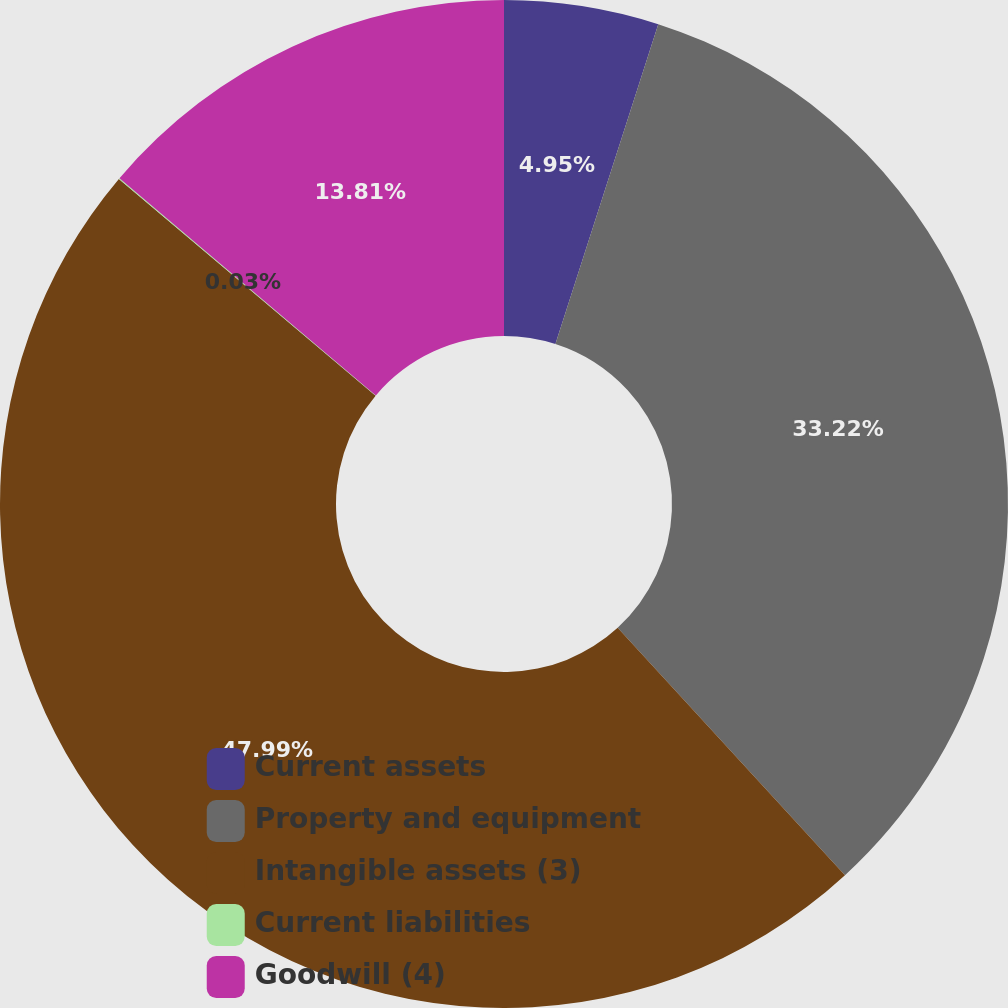Convert chart to OTSL. <chart><loc_0><loc_0><loc_500><loc_500><pie_chart><fcel>Current assets<fcel>Property and equipment<fcel>Intangible assets (3)<fcel>Current liabilities<fcel>Goodwill (4)<nl><fcel>4.95%<fcel>33.22%<fcel>47.98%<fcel>0.03%<fcel>13.81%<nl></chart> 